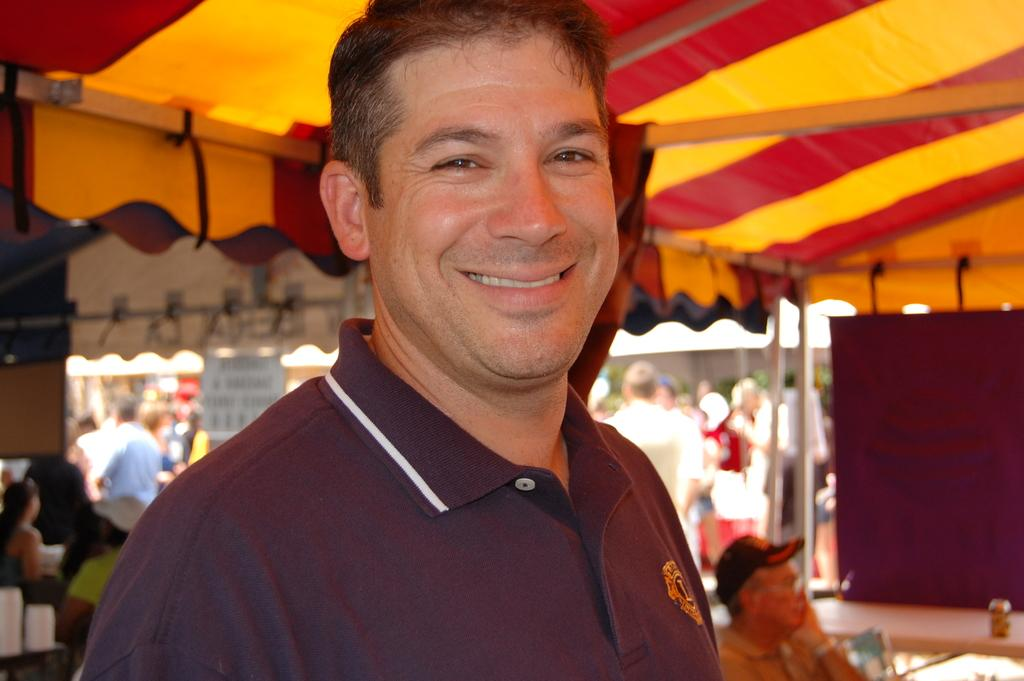Who is the main subject in the image? There is a man in the image. What is the man doing in the image? The man is standing and smiling. Are there any other people in the image? Yes, there are people standing and sitting behind the man. What else can be seen in the image? There are tents in the image. What type of nut is being cracked by the police in the image? There is no police or nut present in the image. What company is hosting the event in the image? There is no indication of a company hosting an event in the image. 